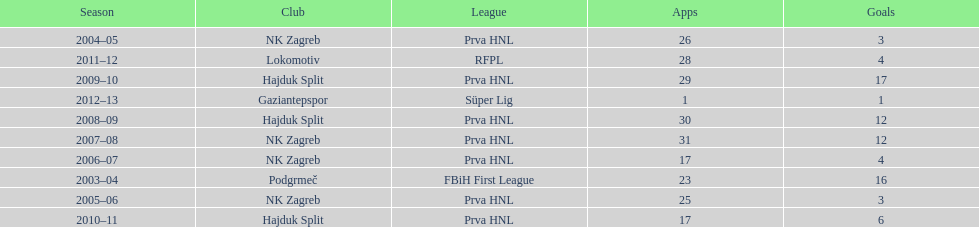The team with the most goals Hajduk Split. 